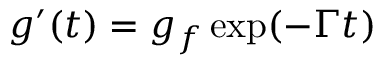<formula> <loc_0><loc_0><loc_500><loc_500>g ^ { \prime } ( t ) = g _ { f } \exp ( - \Gamma t )</formula> 